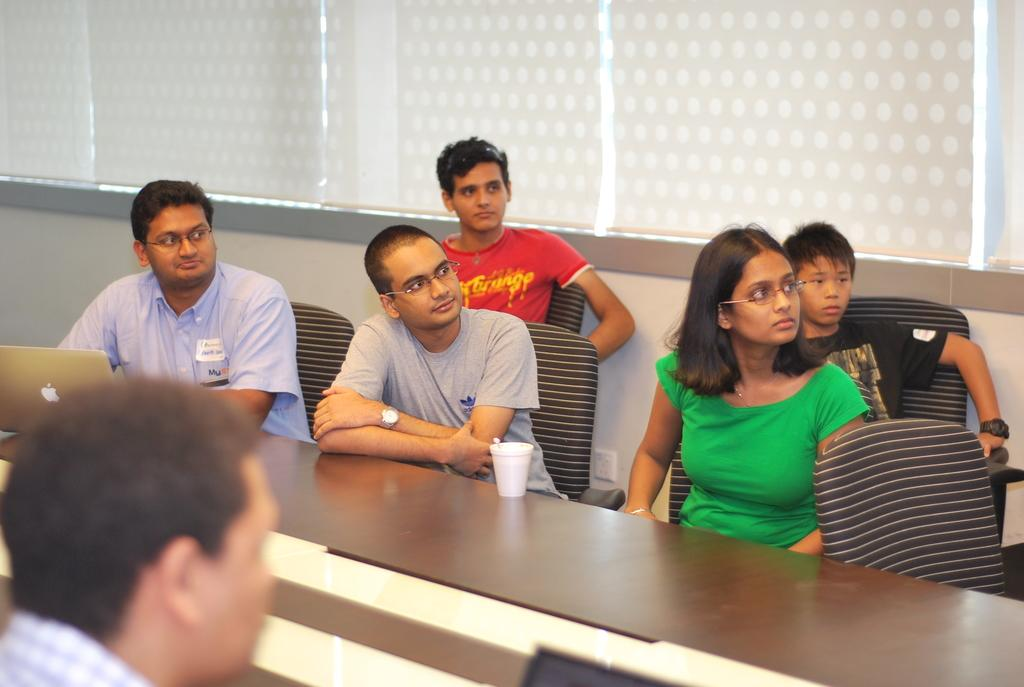What are the people in the image doing? The people in the image are sitting on chairs. Where are the chairs located in relation to the desk? The chairs are in front of the desk. What can be seen on the desk in the image? There is a glass and a laptop on the desk. What is present in the background of the image? There are window blinds in the background of the image. What grade did the people in the image receive on their recent exam? There is no information about an exam or grades in the image. How did the people in the image celebrate their holiday? There is no indication of a holiday or celebration in the image. 